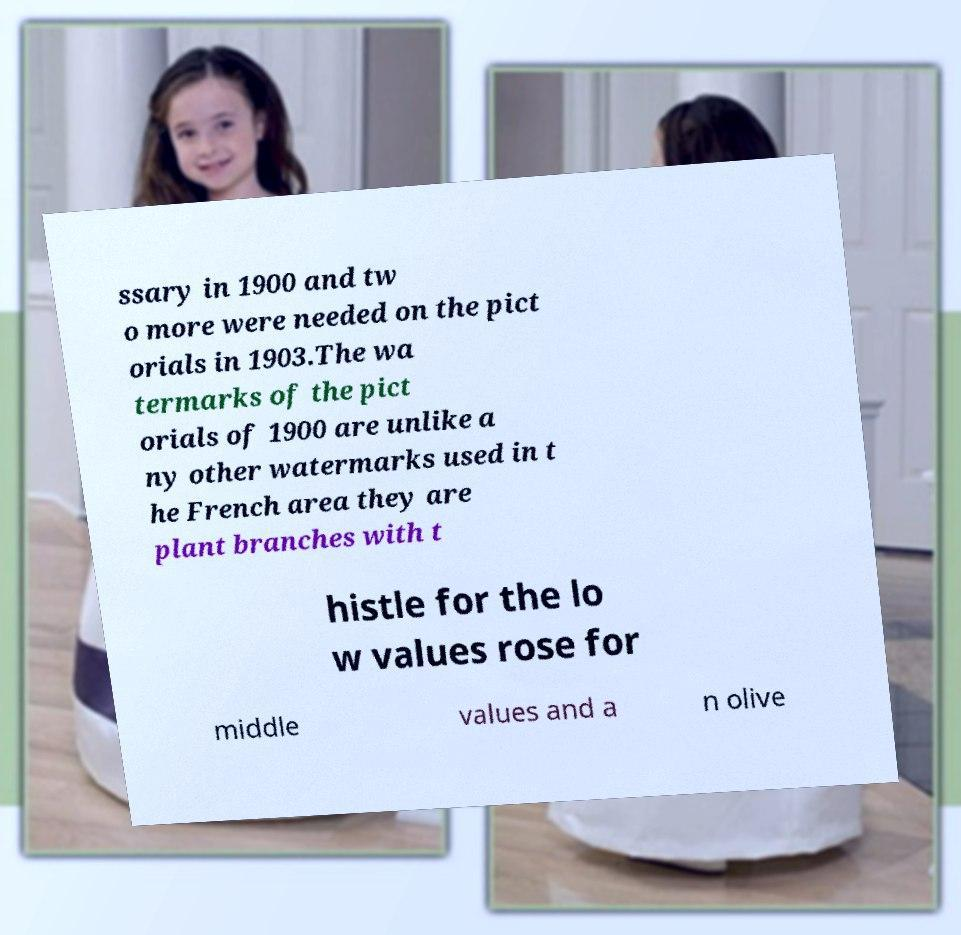Please read and relay the text visible in this image. What does it say? ssary in 1900 and tw o more were needed on the pict orials in 1903.The wa termarks of the pict orials of 1900 are unlike a ny other watermarks used in t he French area they are plant branches with t histle for the lo w values rose for middle values and a n olive 